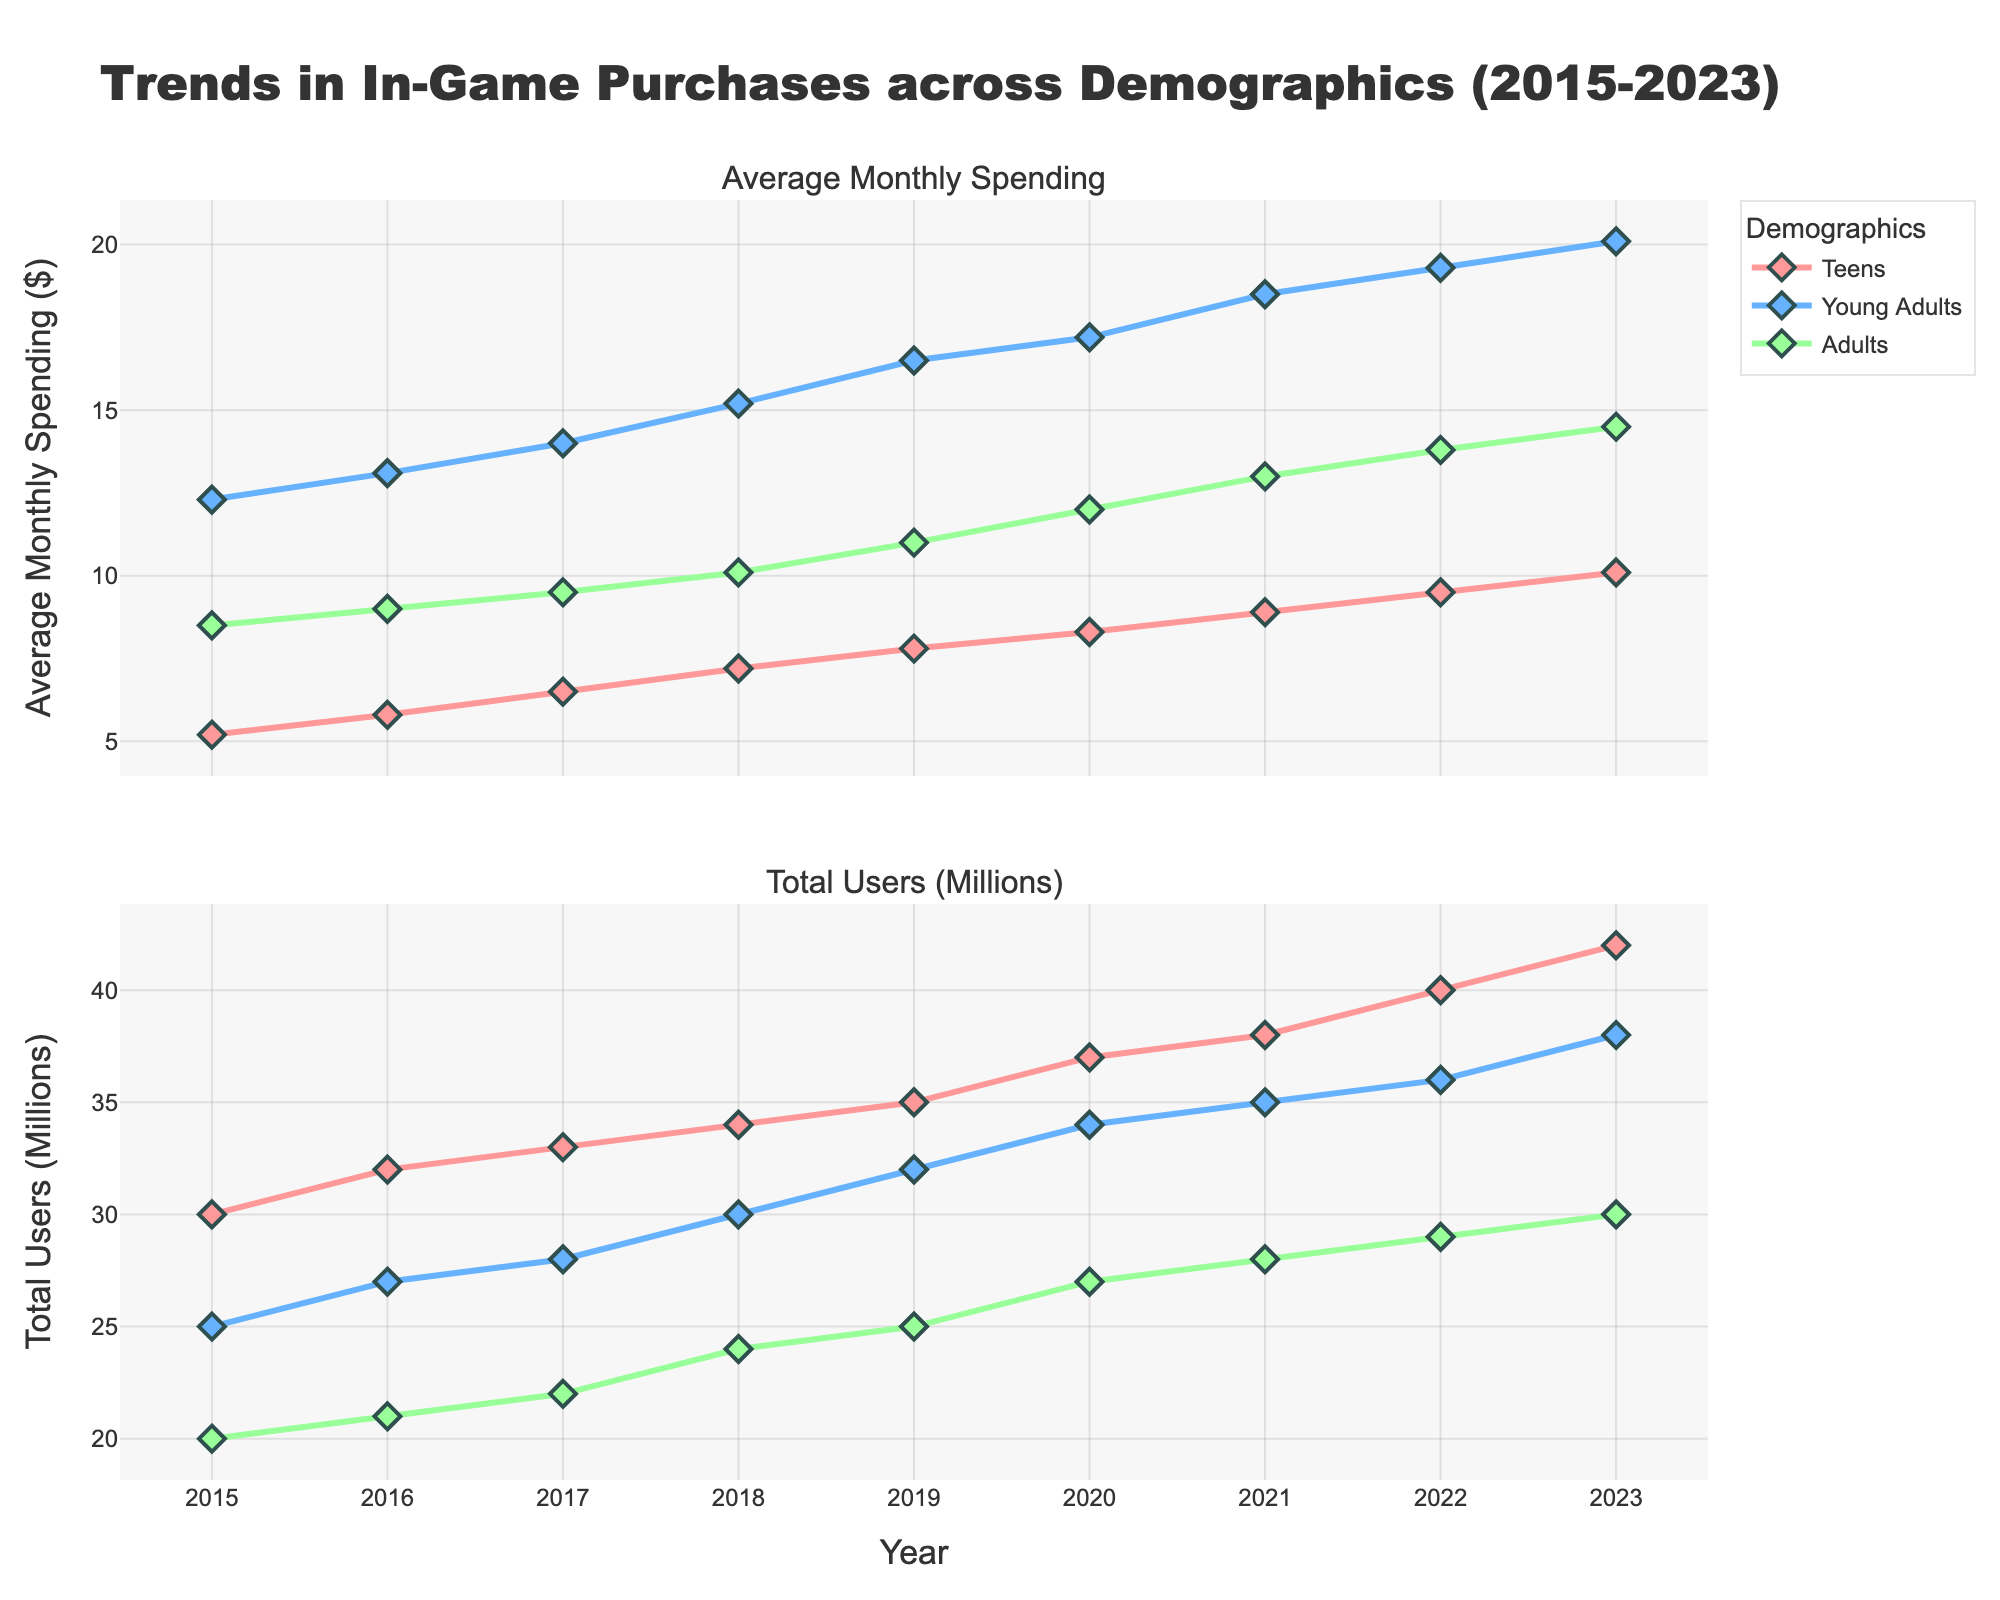what is the title of the figure? The title is usually placed at the top of the figure and gives an overview of what the plot is about. By reading the title, we can understand that the figure describes trends in in-game purchases across different demographics over a period of time from 2015 to 2023.
Answer: Trends in In-Game Purchases across Demographics (2015-2023) Which demographic had the highest average monthly spending in 2021? First, locate the year 2021 on the x-axis of the top subplot. Then, compare the y-values (average monthly spending) for each demographic represented by different colored lines with markers. Identify the highest point among them.
Answer: Young Adults What was the total number of users (in millions) for Teens in 2019? Navigate to the bottom subplot and find the year 2019 on the x-axis. Then, check the corresponding y-value for the Teens demographic's line, indicated by color. This tells us the total number of users in millions.
Answer: 35 million How much did the average monthly spending by Adults change from 2015 to 2023? First, identify the average monthly spending for Adults in the years 2015 and 2023 from the top subplot. The values are $8.50 for 2015 and $14.50 for 2023. Calculate the difference between these two values.
Answer: $6.00 What is the trend in total users for Young Adults from 2015 to 2023? In the bottom subplot, observe the line representing Young Adults from 2015 to 2023. Look for patterns such as if the line is generally increasing, decreasing, or staying constant over time. Since the line shows a clear upward slope, it indicates an increasing trend.
Answer: Increasing Rank the demographics by average monthly spending in 2023 from highest to lowest. From the top subplot for the year 2023, observe the y-values of each demographic's line. Rank the values from highest to lowest. This represents the average monthly spending for each demographic.
Answer: Young Adults > Adults > Teens Which year did Teens surpass an average monthly spending of $8.00? In the top subplot, follow the line for Teens. Identify the first year when the y-value crosses the $8.00 mark. This involves starting from the left at 2015 and observing each point until you get to the point where it exceeds $8.00.
Answer: 2020 What is the difference in total users between Young Adults and Adults in 2022? In the bottom subplot for the year 2022, find the y-values for Young Adults and Adults. Subtract the number of users for Adults from the number of users for Young Adults. The values are 36 million for Young Adults and 29 million for Adults. The difference is 36 - 29 = 7 million.
Answer: 7 million Compare the increase in average monthly spending for Teens and Young Adults from 2015 to 2020. Which demographic saw a greater increase, and by how much? Find the average monthly spending for both Teens and Young Adults in 2015 and 2020 from the top subplot. For Teens, it increased from $5.20 to $8.30, resulting in an increase of $3.10. For Young Adults, it increased from $12.30 to $17.20, resulting in an increase of $4.90. The difference between these increases is $4.90 - $3.10 = $1.80.
Answer: Young Adults; $1.80 In which year did Adults' total number of users exceed 25 million? In the bottom subplot, observe the line for Adults and identify the year in which the y-value surpasses 25 million. This requires following the Adults line from left to right until it exceeds the value of 25 on the y-axis.
Answer: 2020 